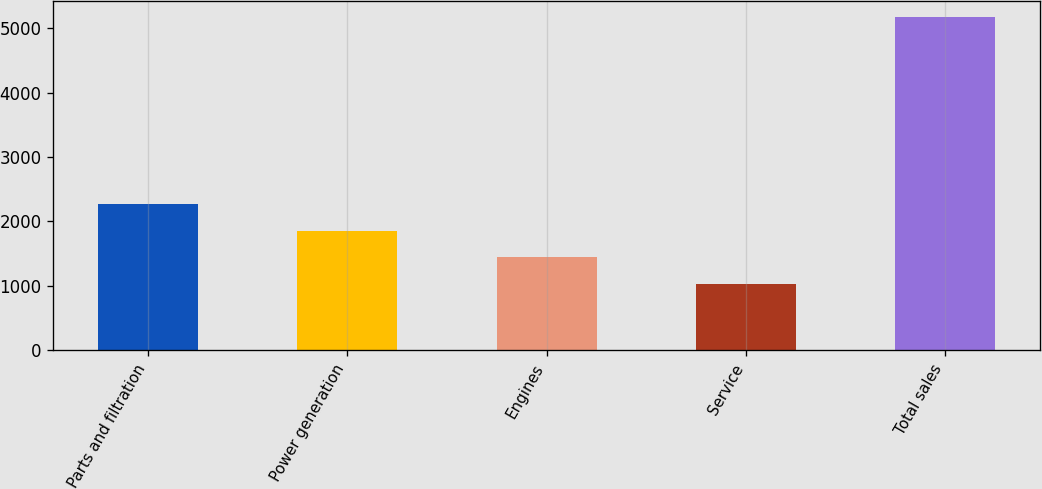<chart> <loc_0><loc_0><loc_500><loc_500><bar_chart><fcel>Parts and filtration<fcel>Power generation<fcel>Engines<fcel>Service<fcel>Total sales<nl><fcel>2270.4<fcel>1855.6<fcel>1440.8<fcel>1026<fcel>5174<nl></chart> 